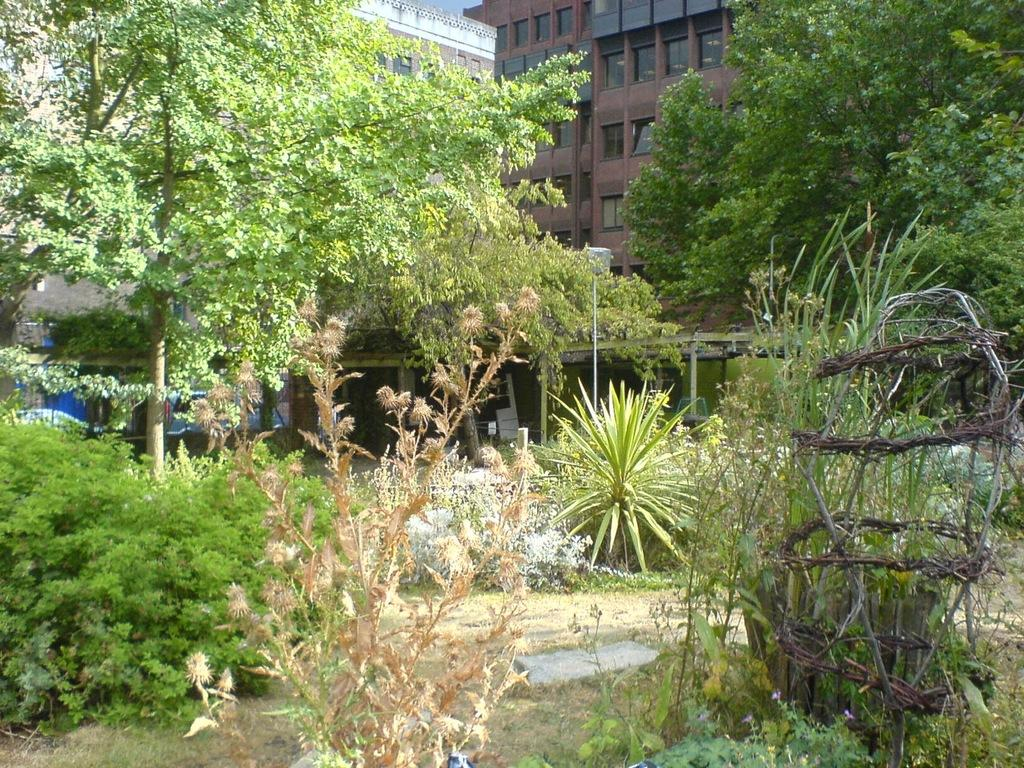What type of vegetation can be seen in the image? There are plants and trees in the image. Where are the trees located in relation to the image? The trees are in the front of the image. What can be seen in the background of the image? There is a pole and buildings in the background of the image. How many vehicles are visible on the left side of the image? There are two vehicles on the left side of the image. What type of paste is being used to hold the bricks together in the image? There are no bricks or paste present in the image. How many horses can be seen grazing in the field in the image? There are no horses or fields present in the image. 